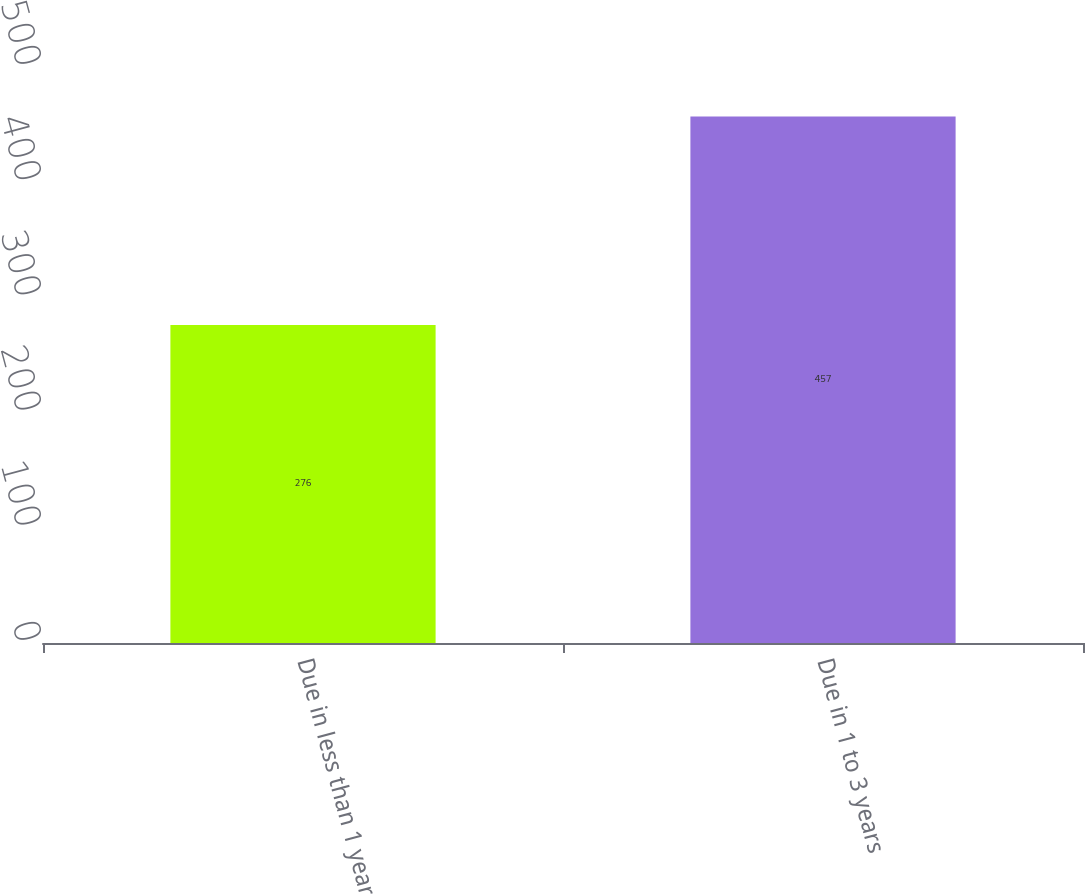Convert chart. <chart><loc_0><loc_0><loc_500><loc_500><bar_chart><fcel>Due in less than 1 year<fcel>Due in 1 to 3 years<nl><fcel>276<fcel>457<nl></chart> 